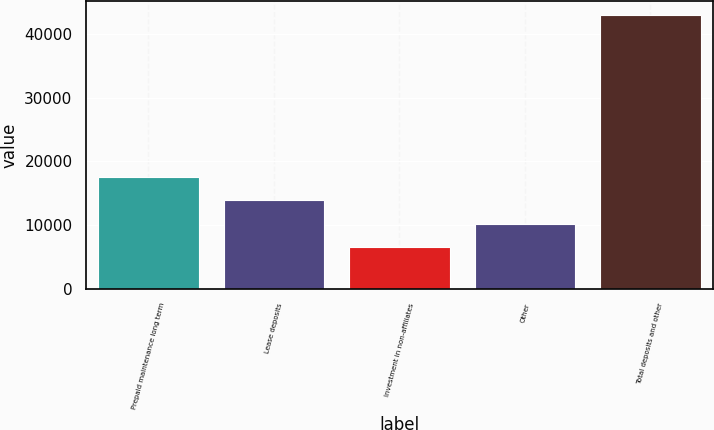Convert chart. <chart><loc_0><loc_0><loc_500><loc_500><bar_chart><fcel>Prepaid maintenance long term<fcel>Lease deposits<fcel>Investment in non-affiliates<fcel>Other<fcel>Total deposits and other<nl><fcel>17519.4<fcel>13889.6<fcel>6630<fcel>10259.8<fcel>42928<nl></chart> 